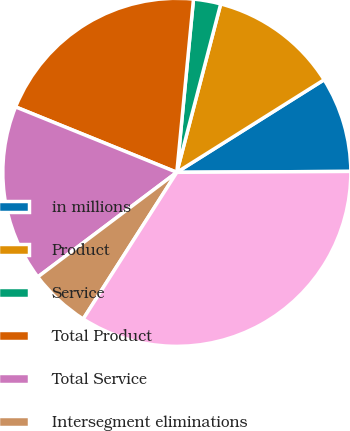Convert chart to OTSL. <chart><loc_0><loc_0><loc_500><loc_500><pie_chart><fcel>in millions<fcel>Product<fcel>Service<fcel>Total Product<fcel>Total Service<fcel>Intersegment eliminations<fcel>Total Segment (1)<nl><fcel>8.85%<fcel>12.01%<fcel>2.53%<fcel>20.39%<fcel>16.4%<fcel>5.69%<fcel>34.12%<nl></chart> 